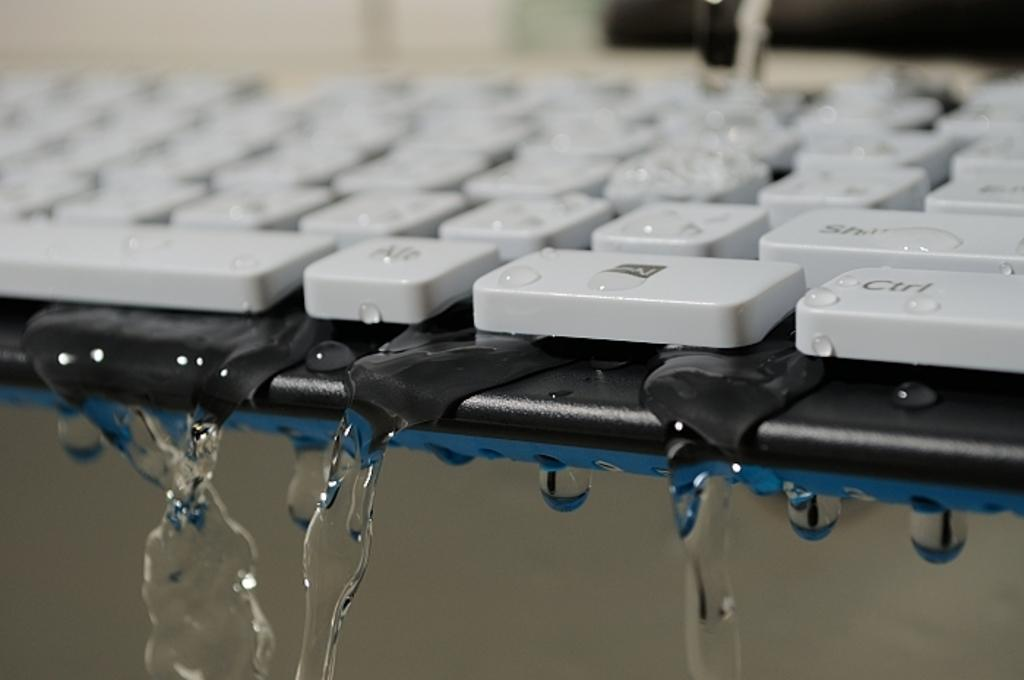Provide a one-sentence caption for the provided image. Water drips from the Ctrl and Alt keys on a keyboard, among others. 